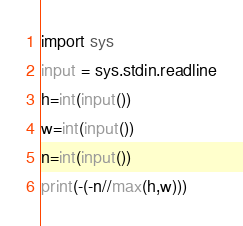<code> <loc_0><loc_0><loc_500><loc_500><_Python_>import sys
input = sys.stdin.readline
h=int(input())
w=int(input())
n=int(input())
print(-(-n//max(h,w)))
</code> 